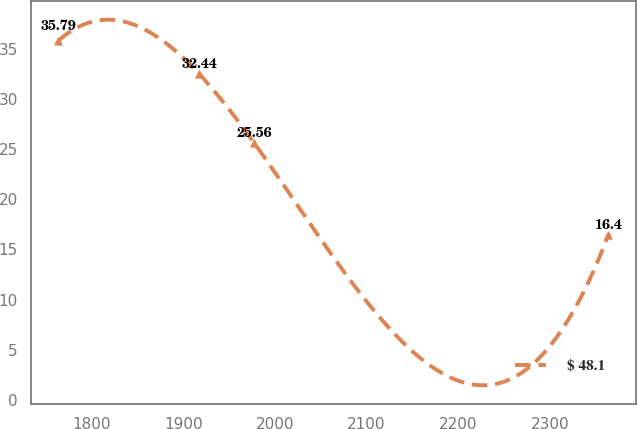Convert chart. <chart><loc_0><loc_0><loc_500><loc_500><line_chart><ecel><fcel>$ 48.1<nl><fcel>1763.83<fcel>35.79<nl><fcel>1917.64<fcel>32.44<nl><fcel>1977.62<fcel>25.56<nl><fcel>2363.68<fcel>16.4<nl></chart> 